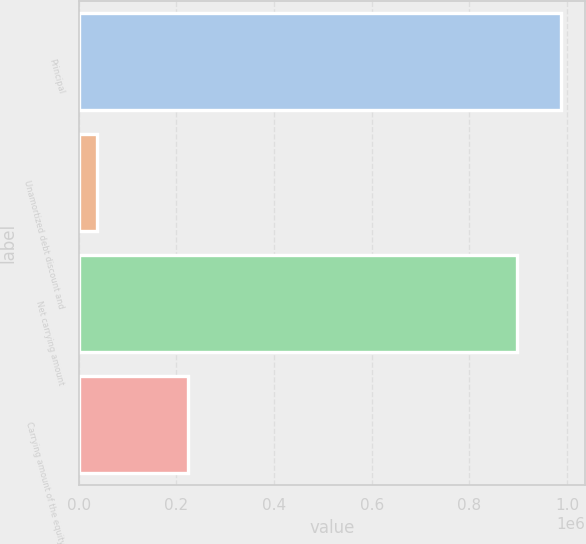Convert chart to OTSL. <chart><loc_0><loc_0><loc_500><loc_500><bar_chart><fcel>Principal<fcel>Unamortized debt discount and<fcel>Net carrying amount<fcel>Carrying amount of the equity<nl><fcel>987061<fcel>37672<fcel>897328<fcel>222826<nl></chart> 